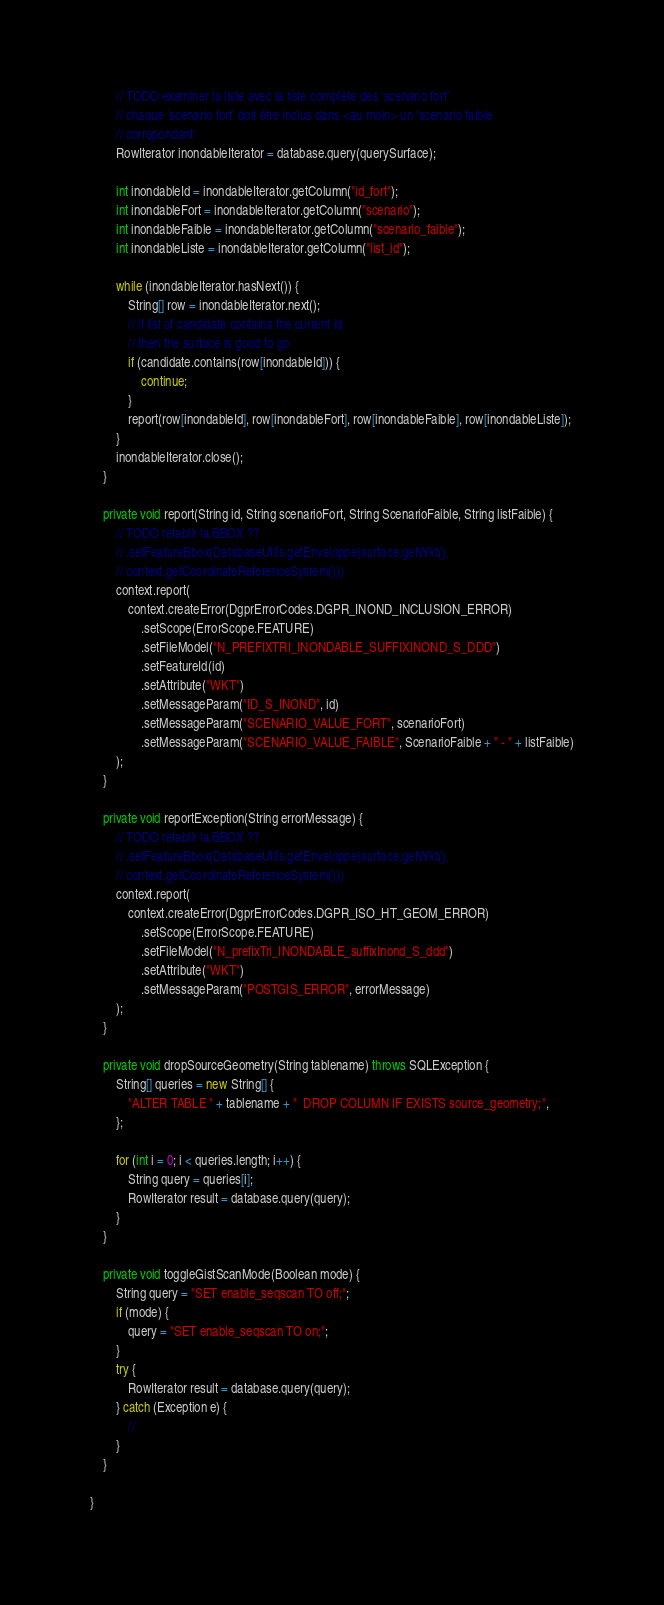Convert code to text. <code><loc_0><loc_0><loc_500><loc_500><_Java_>        // TODO examiner la liste avec la liste complète des 'scenario fort'
        // chaque 'scenario fort' doit être inclus dans <au moin> un 'scenario faible
        // correpondant'
        RowIterator inondableIterator = database.query(querySurface);

        int inondableId = inondableIterator.getColumn("id_fort");
        int inondableFort = inondableIterator.getColumn("scenario");
        int inondableFaible = inondableIterator.getColumn("scenario_faible");
        int inondableListe = inondableIterator.getColumn("list_id");

        while (inondableIterator.hasNext()) {
            String[] row = inondableIterator.next();
            // if list of candidate contains the current id
            // then the surface is good to go
            if (candidate.contains(row[inondableId])) {
                continue;
            }
            report(row[inondableId], row[inondableFort], row[inondableFaible], row[inondableListe]);
        }
        inondableIterator.close();
    }

    private void report(String id, String scenarioFort, String ScenarioFaible, String listFaible) {
        // TODO retablir la BBOX ??
        // .setFeatureBbox(DatabaseUtils.getEnveloppe(surface.getWkt(),
        // context.getCoordinateReferenceSystem()))
        context.report(
            context.createError(DgprErrorCodes.DGPR_INOND_INCLUSION_ERROR)
                .setScope(ErrorScope.FEATURE)
                .setFileModel("N_PREFIXTRI_INONDABLE_SUFFIXINOND_S_DDD")
                .setFeatureId(id)
                .setAttribute("WKT")
                .setMessageParam("ID_S_INOND", id)
                .setMessageParam("SCENARIO_VALUE_FORT", scenarioFort)
                .setMessageParam("SCENARIO_VALUE_FAIBLE", ScenarioFaible + " - " + listFaible)
        );
    }

    private void reportException(String errorMessage) {
        // TODO retablir la BBOX ??
        // .setFeatureBbox(DatabaseUtils.getEnveloppe(surface.getWkt(),
        // context.getCoordinateReferenceSystem()))
        context.report(
            context.createError(DgprErrorCodes.DGPR_ISO_HT_GEOM_ERROR)
                .setScope(ErrorScope.FEATURE)
                .setFileModel("N_prefixTri_INONDABLE_suffixInond_S_ddd")
                .setAttribute("WKT")
                .setMessageParam("POSTGIS_ERROR", errorMessage)
        );
    }

    private void dropSourceGeometry(String tablename) throws SQLException {
        String[] queries = new String[] {
            "ALTER TABLE " + tablename + "  DROP COLUMN IF EXISTS source_geometry;",
        };

        for (int i = 0; i < queries.length; i++) {
            String query = queries[i];
            RowIterator result = database.query(query);
        }
    }

    private void toggleGistScanMode(Boolean mode) {
        String query = "SET enable_seqscan TO off;";
        if (mode) {
            query = "SET enable_seqscan TO on;";
        }
        try {
            RowIterator result = database.query(query);
        } catch (Exception e) {
            //
        }
    }

}
</code> 